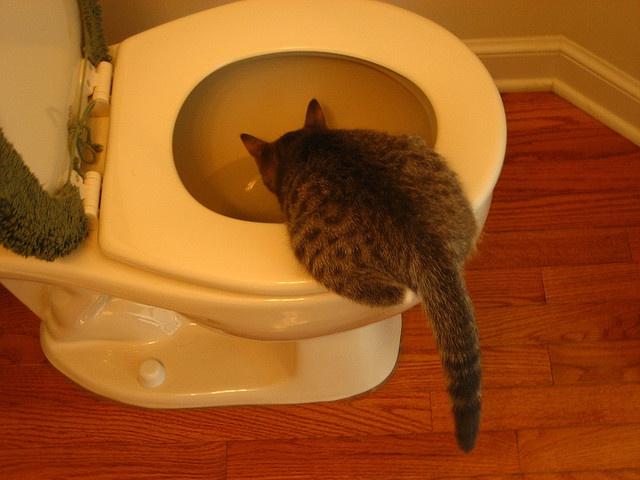Describe the objects in this image and their specific colors. I can see toilet in tan, orange, and olive tones and cat in tan, maroon, black, and brown tones in this image. 